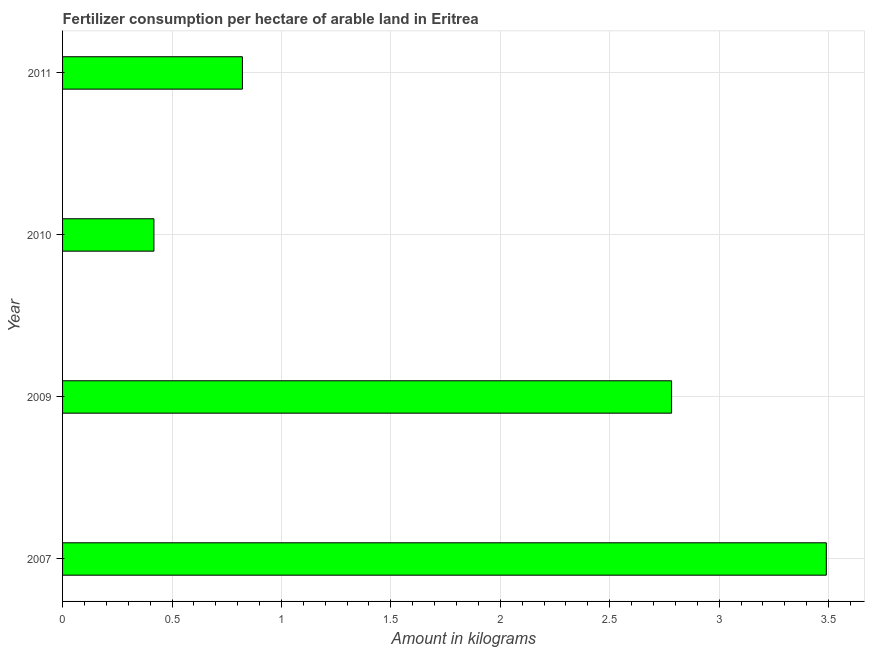What is the title of the graph?
Keep it short and to the point. Fertilizer consumption per hectare of arable land in Eritrea . What is the label or title of the X-axis?
Make the answer very short. Amount in kilograms. What is the amount of fertilizer consumption in 2010?
Provide a short and direct response. 0.42. Across all years, what is the maximum amount of fertilizer consumption?
Make the answer very short. 3.49. Across all years, what is the minimum amount of fertilizer consumption?
Ensure brevity in your answer.  0.42. In which year was the amount of fertilizer consumption minimum?
Make the answer very short. 2010. What is the sum of the amount of fertilizer consumption?
Make the answer very short. 7.51. What is the difference between the amount of fertilizer consumption in 2009 and 2010?
Ensure brevity in your answer.  2.37. What is the average amount of fertilizer consumption per year?
Offer a terse response. 1.88. What is the median amount of fertilizer consumption?
Provide a short and direct response. 1.8. In how many years, is the amount of fertilizer consumption greater than 3 kg?
Give a very brief answer. 1. What is the ratio of the amount of fertilizer consumption in 2007 to that in 2009?
Your response must be concise. 1.25. What is the difference between the highest and the second highest amount of fertilizer consumption?
Provide a succinct answer. 0.71. What is the difference between the highest and the lowest amount of fertilizer consumption?
Your answer should be very brief. 3.07. How many years are there in the graph?
Your response must be concise. 4. What is the difference between two consecutive major ticks on the X-axis?
Your answer should be compact. 0.5. What is the Amount in kilograms of 2007?
Make the answer very short. 3.49. What is the Amount in kilograms of 2009?
Offer a very short reply. 2.78. What is the Amount in kilograms of 2010?
Provide a short and direct response. 0.42. What is the Amount in kilograms of 2011?
Ensure brevity in your answer.  0.82. What is the difference between the Amount in kilograms in 2007 and 2009?
Keep it short and to the point. 0.71. What is the difference between the Amount in kilograms in 2007 and 2010?
Make the answer very short. 3.07. What is the difference between the Amount in kilograms in 2007 and 2011?
Keep it short and to the point. 2.67. What is the difference between the Amount in kilograms in 2009 and 2010?
Offer a very short reply. 2.37. What is the difference between the Amount in kilograms in 2009 and 2011?
Provide a succinct answer. 1.96. What is the difference between the Amount in kilograms in 2010 and 2011?
Your answer should be compact. -0.4. What is the ratio of the Amount in kilograms in 2007 to that in 2009?
Provide a short and direct response. 1.25. What is the ratio of the Amount in kilograms in 2007 to that in 2010?
Your answer should be compact. 8.36. What is the ratio of the Amount in kilograms in 2007 to that in 2011?
Ensure brevity in your answer.  4.25. What is the ratio of the Amount in kilograms in 2009 to that in 2010?
Offer a terse response. 6.67. What is the ratio of the Amount in kilograms in 2009 to that in 2011?
Make the answer very short. 3.39. What is the ratio of the Amount in kilograms in 2010 to that in 2011?
Offer a terse response. 0.51. 